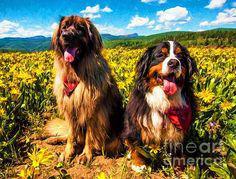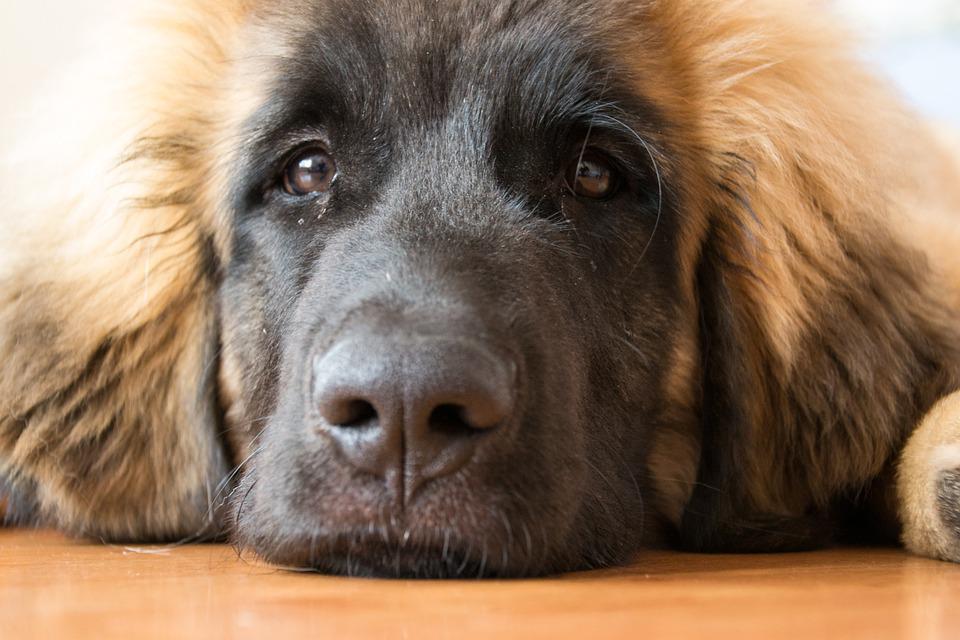The first image is the image on the left, the second image is the image on the right. Considering the images on both sides, is "Two dogs wearing something around their necks are posed side-by-side outdoors in front of yellow foliage." valid? Answer yes or no. Yes. 